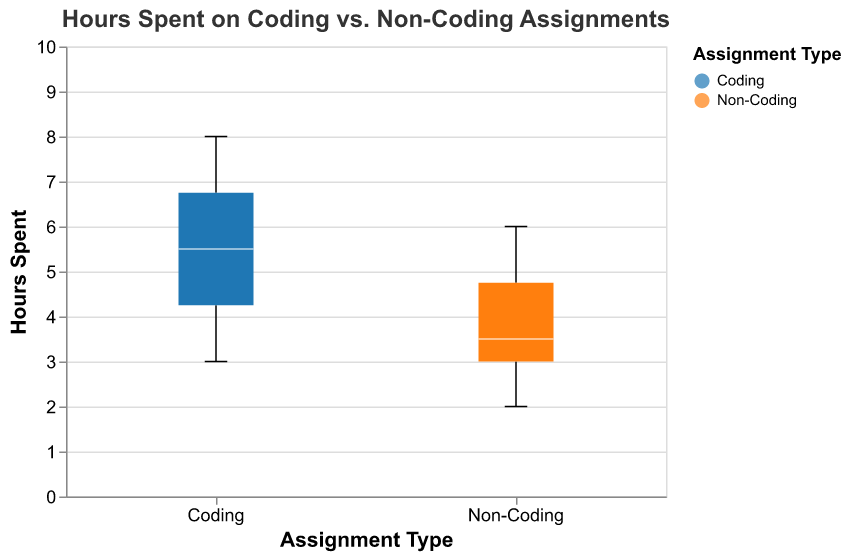What is the title of the figure? The title is usually located at the top of the figure and provides a brief description of what the figure is about.
Answer: Hours Spent on Coding vs. Non-Coding Assignments How many categories of assignments are represented in the figure? Look at the x-axis where the assignment types are labeled. Count the distinct categories.
Answer: 2 What are the two assignment types compared in the figure? The x-axis labels and the legend will show the names of the two categories being compared.
Answer: Coding and Non-Coding What is the color associated with "Coding" assignments? Refer to the legend on the right side or next to the figure where each assignment type's color is indicated.
Answer: Blue Which assignment type has a higher median value for hours spent? Look at the median line within each boxplot. The median is usually highlighted as a white line. Compare the two median values.
Answer: Coding What is the range of hours spent on Non-Coding assignments? The range is given by the minimum and maximum values represented by the "whiskers" which extend from the box.
Answer: 2 to 6 What is the interquartile range (IQR) of hours spent on Coding assignments? The IQR is the range between the first quartile (bottom edge of the box) and third quartile (top edge of the box) on the boxplot.
Answer: 4 to 7 How do the median hours spent on Coding and Non-Coding assignments compare? Find the median value (white line) for both the Coding and Non-Coding boxplots. See which is higher or if they are equal.
Answer: Coding has a higher median Are there any outliers in the data? If so, how are they indicated? Outliers are often shown as dots outside the whiskers of a boxplot. Look for any such dots.
Answer: No outliers Which assignment type shows a greater variability in hours spent based on the IQR? The IQR indicates the spread of the middle 50% of the data. A wider IQR means more variability. Compare the height of the boxes between the two categories.
Answer: Coding 